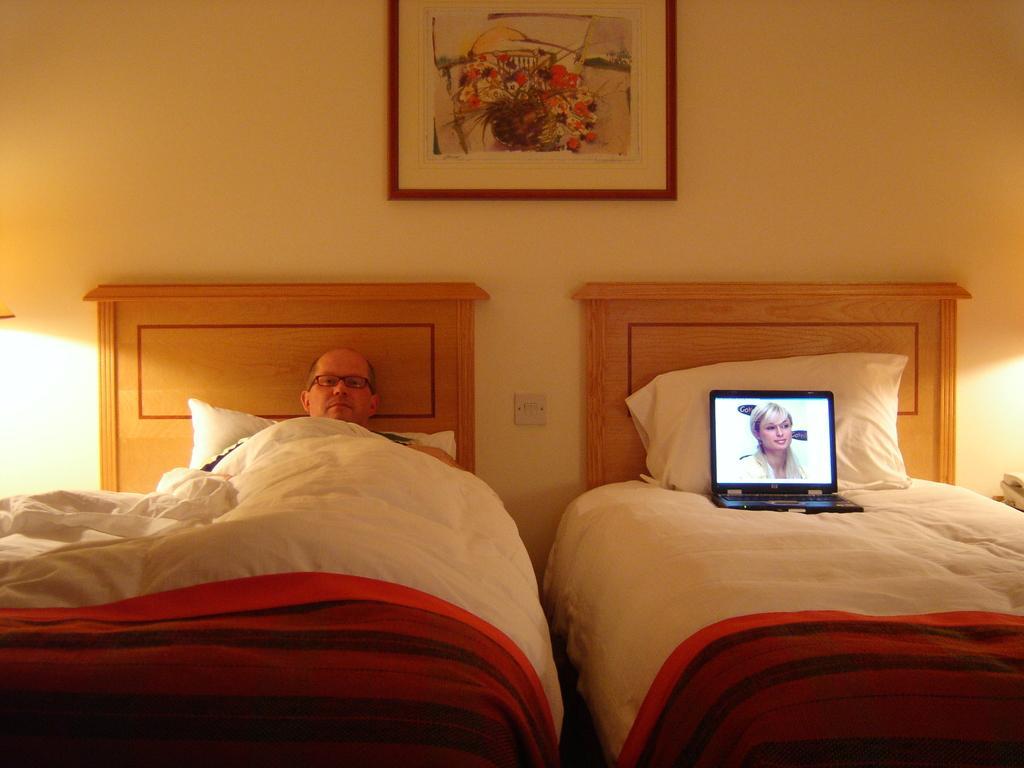In one or two sentences, can you explain what this image depicts? In this picture i could see a person laying on the bed with quilt on him and on the other bed i could see a laptop on the bed. In the background i could see a wall and a picture frame hanging on the wall. 